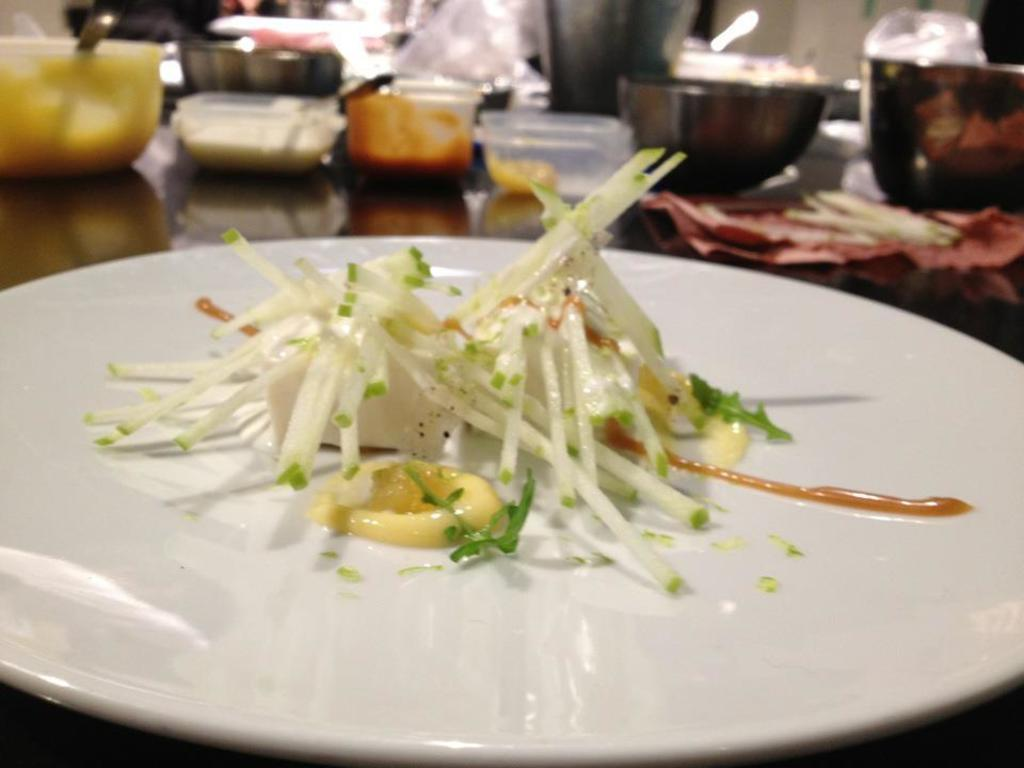What piece of furniture is present in the image? There is a table in the image. What is placed on the table? There is a plate on the table, and it contains food items. Are there any other containers on the table? Yes, there are bowls on the table. What else can be seen on the table? There are boxes on the table, as well as other objects. How many stars can be seen on the table in the image? There are no stars present on the table in the image. What type of line is drawn on the plate in the image? There is no line drawn on the plate in the image. 